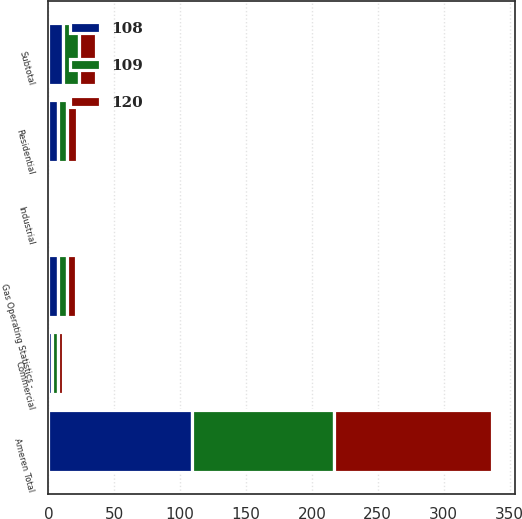Convert chart. <chart><loc_0><loc_0><loc_500><loc_500><stacked_bar_chart><ecel><fcel>Gas Operating Statistics -<fcel>Residential<fcel>Commercial<fcel>Industrial<fcel>Subtotal<fcel>Ameren Total<nl><fcel>120<fcel>7<fcel>8<fcel>4<fcel>1<fcel>13<fcel>120<nl><fcel>109<fcel>7<fcel>7<fcel>4<fcel>1<fcel>12<fcel>108<nl><fcel>108<fcel>7<fcel>7<fcel>3<fcel>1<fcel>11<fcel>109<nl></chart> 